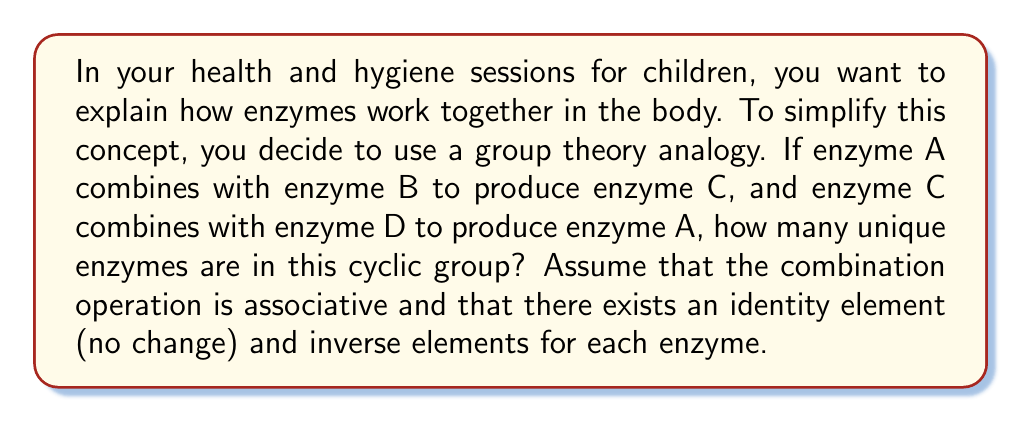Provide a solution to this math problem. To solve this problem, we need to understand the properties of a cyclic group and apply them to the given enzyme interactions:

1. Group structure:
   Let's represent the enzyme combinations as:
   $A * B = C$
   $C * D = A$
   Where $*$ represents the combination operation.

2. Cyclic group properties:
   - A cyclic group is generated by a single element.
   - The order of a cyclic group is the number of unique elements.

3. Analyzing the given information:
   - We have four named enzymes: A, B, C, and D.
   - We need to determine if these are all unique or if some are repetitions.

4. Deducing additional combinations:
   - From $A * B = C$, we can deduce $C * B^{-1} = A$ (using the inverse property)
   - From $C * D = A$, we can deduce $C * D * B = C$ (substituting $A$ with $C * D$)
   - This implies $D * B = e$ (identity element), or $D = B^{-1}$

5. Conclusion:
   - We have shown that D is the inverse of B, so they are not unique elements.
   - The unique elements are A, B, and C.
   - The identity element e is also part of the group.

Therefore, this cyclic group contains 4 unique elements: A, B, C, and e (the identity element).
Answer: 4 unique enzymes 